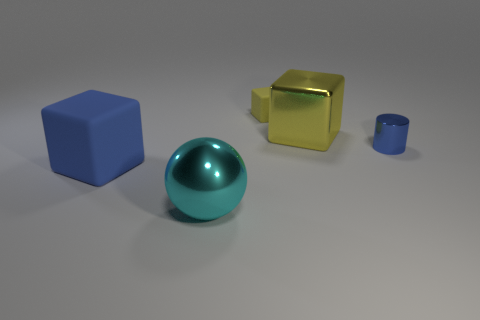Can you tell if these objects are placed indoors or outdoors? It is difficult to ascertain with certainty from this image alone, but given the controlled lighting and lack of environmental details, it suggests that these objects are likely placed indoors in a studio-like setting. What makes you say that? The lack of natural elements like wind, varying light sources, or an outdoor background typically found in an outdoor setting leads me to this conclusion. Moreover, the shadows and reflections are consistent with an environment where lighting can be manipulated, such as a photography studio. 